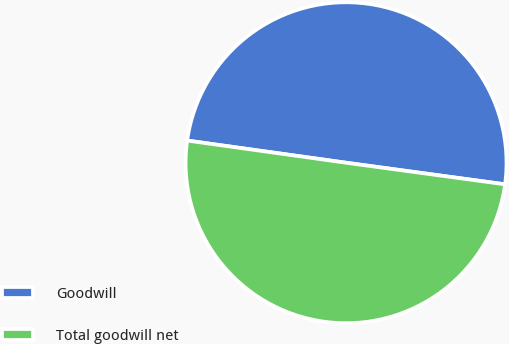Convert chart to OTSL. <chart><loc_0><loc_0><loc_500><loc_500><pie_chart><fcel>Goodwill<fcel>Total goodwill net<nl><fcel>49.94%<fcel>50.06%<nl></chart> 